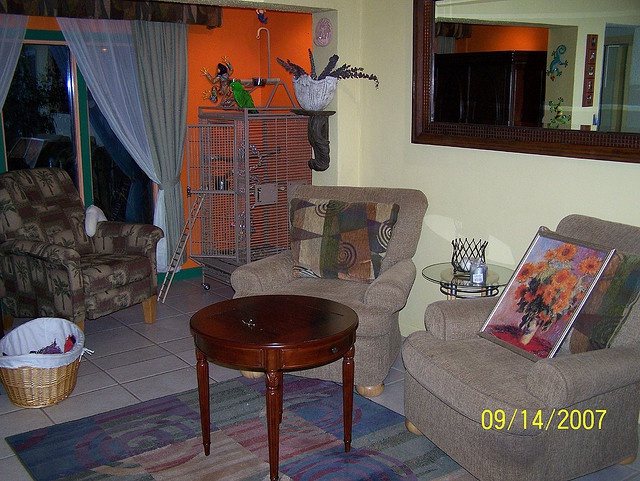Describe the objects in this image and their specific colors. I can see chair in black and gray tones, chair in black, gray, and maroon tones, chair in black and gray tones, potted plant in black, darkgray, and gray tones, and bird in black, darkgreen, gray, and maroon tones in this image. 